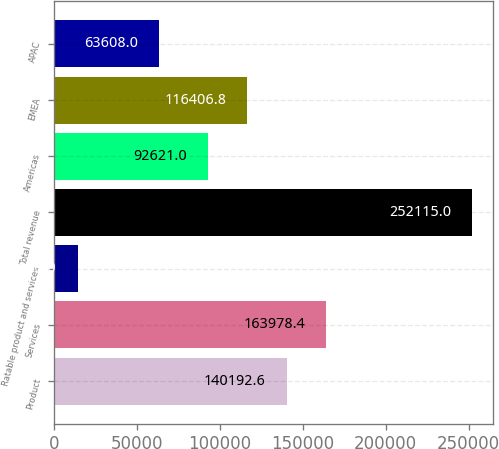<chart> <loc_0><loc_0><loc_500><loc_500><bar_chart><fcel>Product<fcel>Services<fcel>Ratable product and services<fcel>Total revenue<fcel>Americas<fcel>EMEA<fcel>APAC<nl><fcel>140193<fcel>163978<fcel>14257<fcel>252115<fcel>92621<fcel>116407<fcel>63608<nl></chart> 